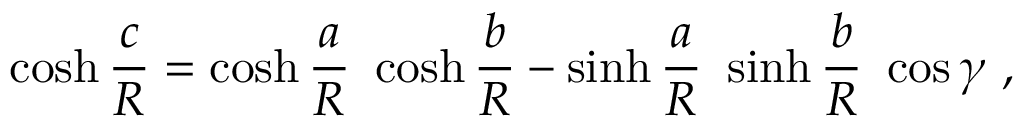<formula> <loc_0><loc_0><loc_500><loc_500>\cosh { \frac { c } { R } } = \cosh { \frac { a } { R } } \ \cosh { \frac { b } { R } } - \sinh { \frac { a } { R } } \ \sinh { \frac { b } { R } } \ \cos \gamma \ ,</formula> 